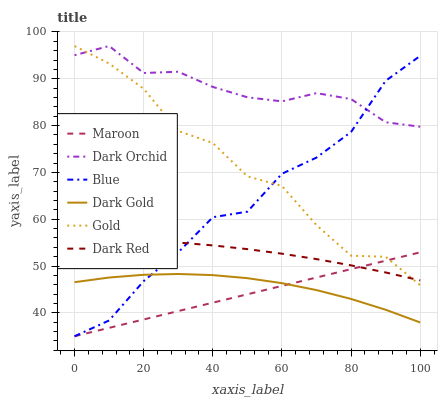Does Maroon have the minimum area under the curve?
Answer yes or no. Yes. Does Dark Orchid have the maximum area under the curve?
Answer yes or no. Yes. Does Gold have the minimum area under the curve?
Answer yes or no. No. Does Gold have the maximum area under the curve?
Answer yes or no. No. Is Maroon the smoothest?
Answer yes or no. Yes. Is Gold the roughest?
Answer yes or no. Yes. Is Dark Gold the smoothest?
Answer yes or no. No. Is Dark Gold the roughest?
Answer yes or no. No. Does Blue have the lowest value?
Answer yes or no. Yes. Does Gold have the lowest value?
Answer yes or no. No. Does Dark Orchid have the highest value?
Answer yes or no. Yes. Does Dark Gold have the highest value?
Answer yes or no. No. Is Dark Gold less than Gold?
Answer yes or no. Yes. Is Dark Orchid greater than Dark Gold?
Answer yes or no. Yes. Does Dark Gold intersect Blue?
Answer yes or no. Yes. Is Dark Gold less than Blue?
Answer yes or no. No. Is Dark Gold greater than Blue?
Answer yes or no. No. Does Dark Gold intersect Gold?
Answer yes or no. No. 